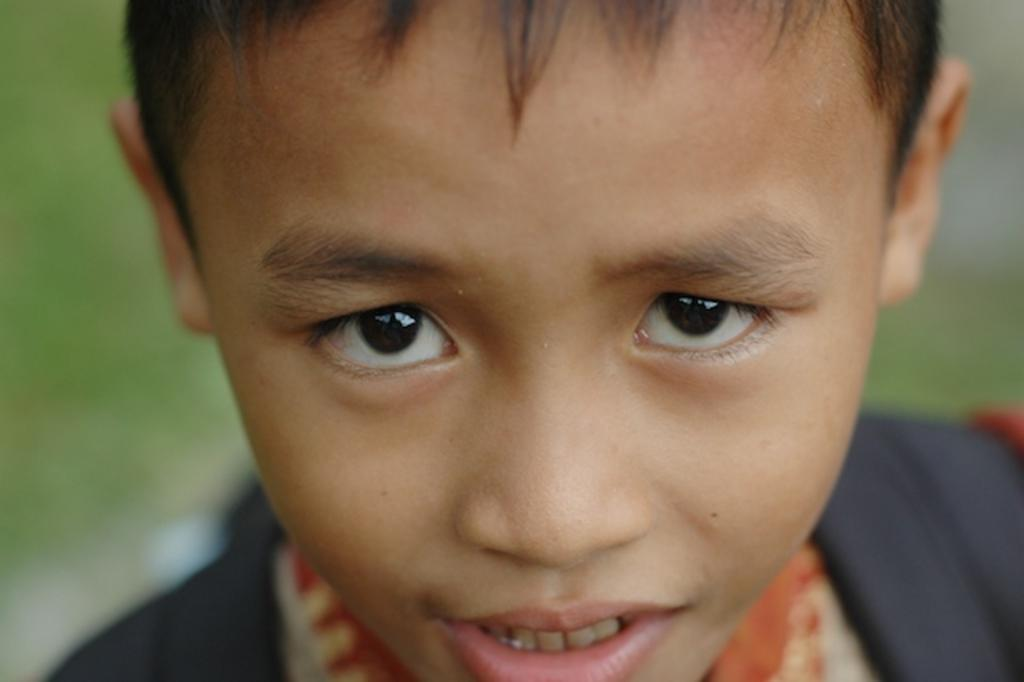Who is the main subject in the image? There is a boy in the image. What is the boy doing in the image? The boy is standing in the image. What is the boy wearing in the image? The boy is wearing a bag in the image. Can you describe the background of the image? The background of the image is blurry. How many sheep are visible in the image? There are no sheep present in the image. What type of jail can be seen in the background of the image? There is no jail present in the image; the background is blurry. 